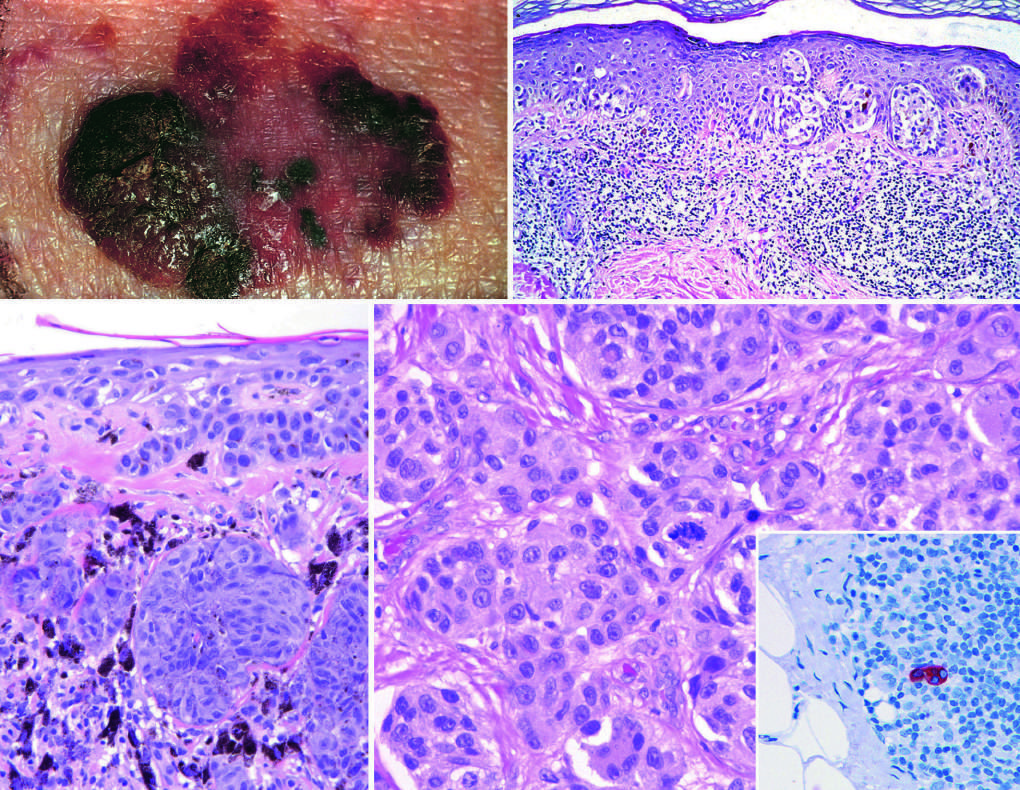s an atypical mitotic figure present in the center of the field?
Answer the question using a single word or phrase. Yes 